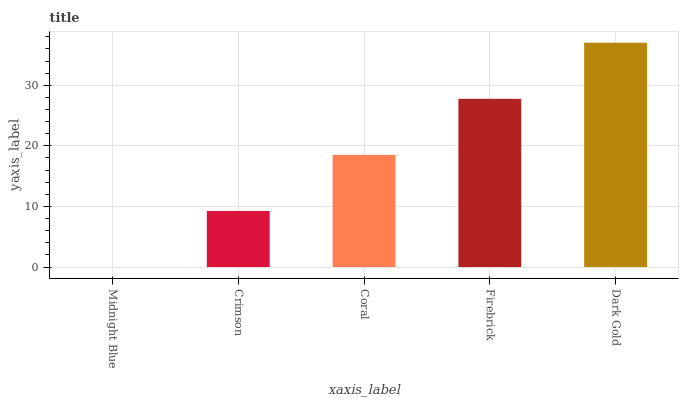Is Crimson the minimum?
Answer yes or no. No. Is Crimson the maximum?
Answer yes or no. No. Is Crimson greater than Midnight Blue?
Answer yes or no. Yes. Is Midnight Blue less than Crimson?
Answer yes or no. Yes. Is Midnight Blue greater than Crimson?
Answer yes or no. No. Is Crimson less than Midnight Blue?
Answer yes or no. No. Is Coral the high median?
Answer yes or no. Yes. Is Coral the low median?
Answer yes or no. Yes. Is Firebrick the high median?
Answer yes or no. No. Is Firebrick the low median?
Answer yes or no. No. 